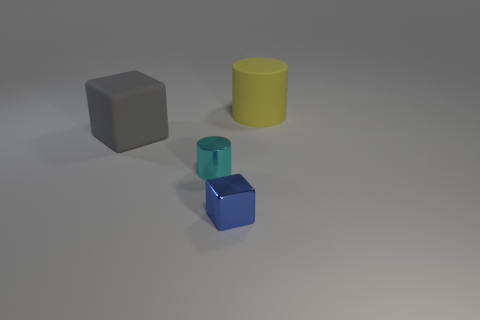Subtract all purple cylinders. Subtract all red spheres. How many cylinders are left? 2 Add 4 tiny metallic objects. How many objects exist? 8 Subtract all large brown cubes. Subtract all large gray rubber objects. How many objects are left? 3 Add 4 big cubes. How many big cubes are left? 5 Add 3 yellow things. How many yellow things exist? 4 Subtract 0 green balls. How many objects are left? 4 